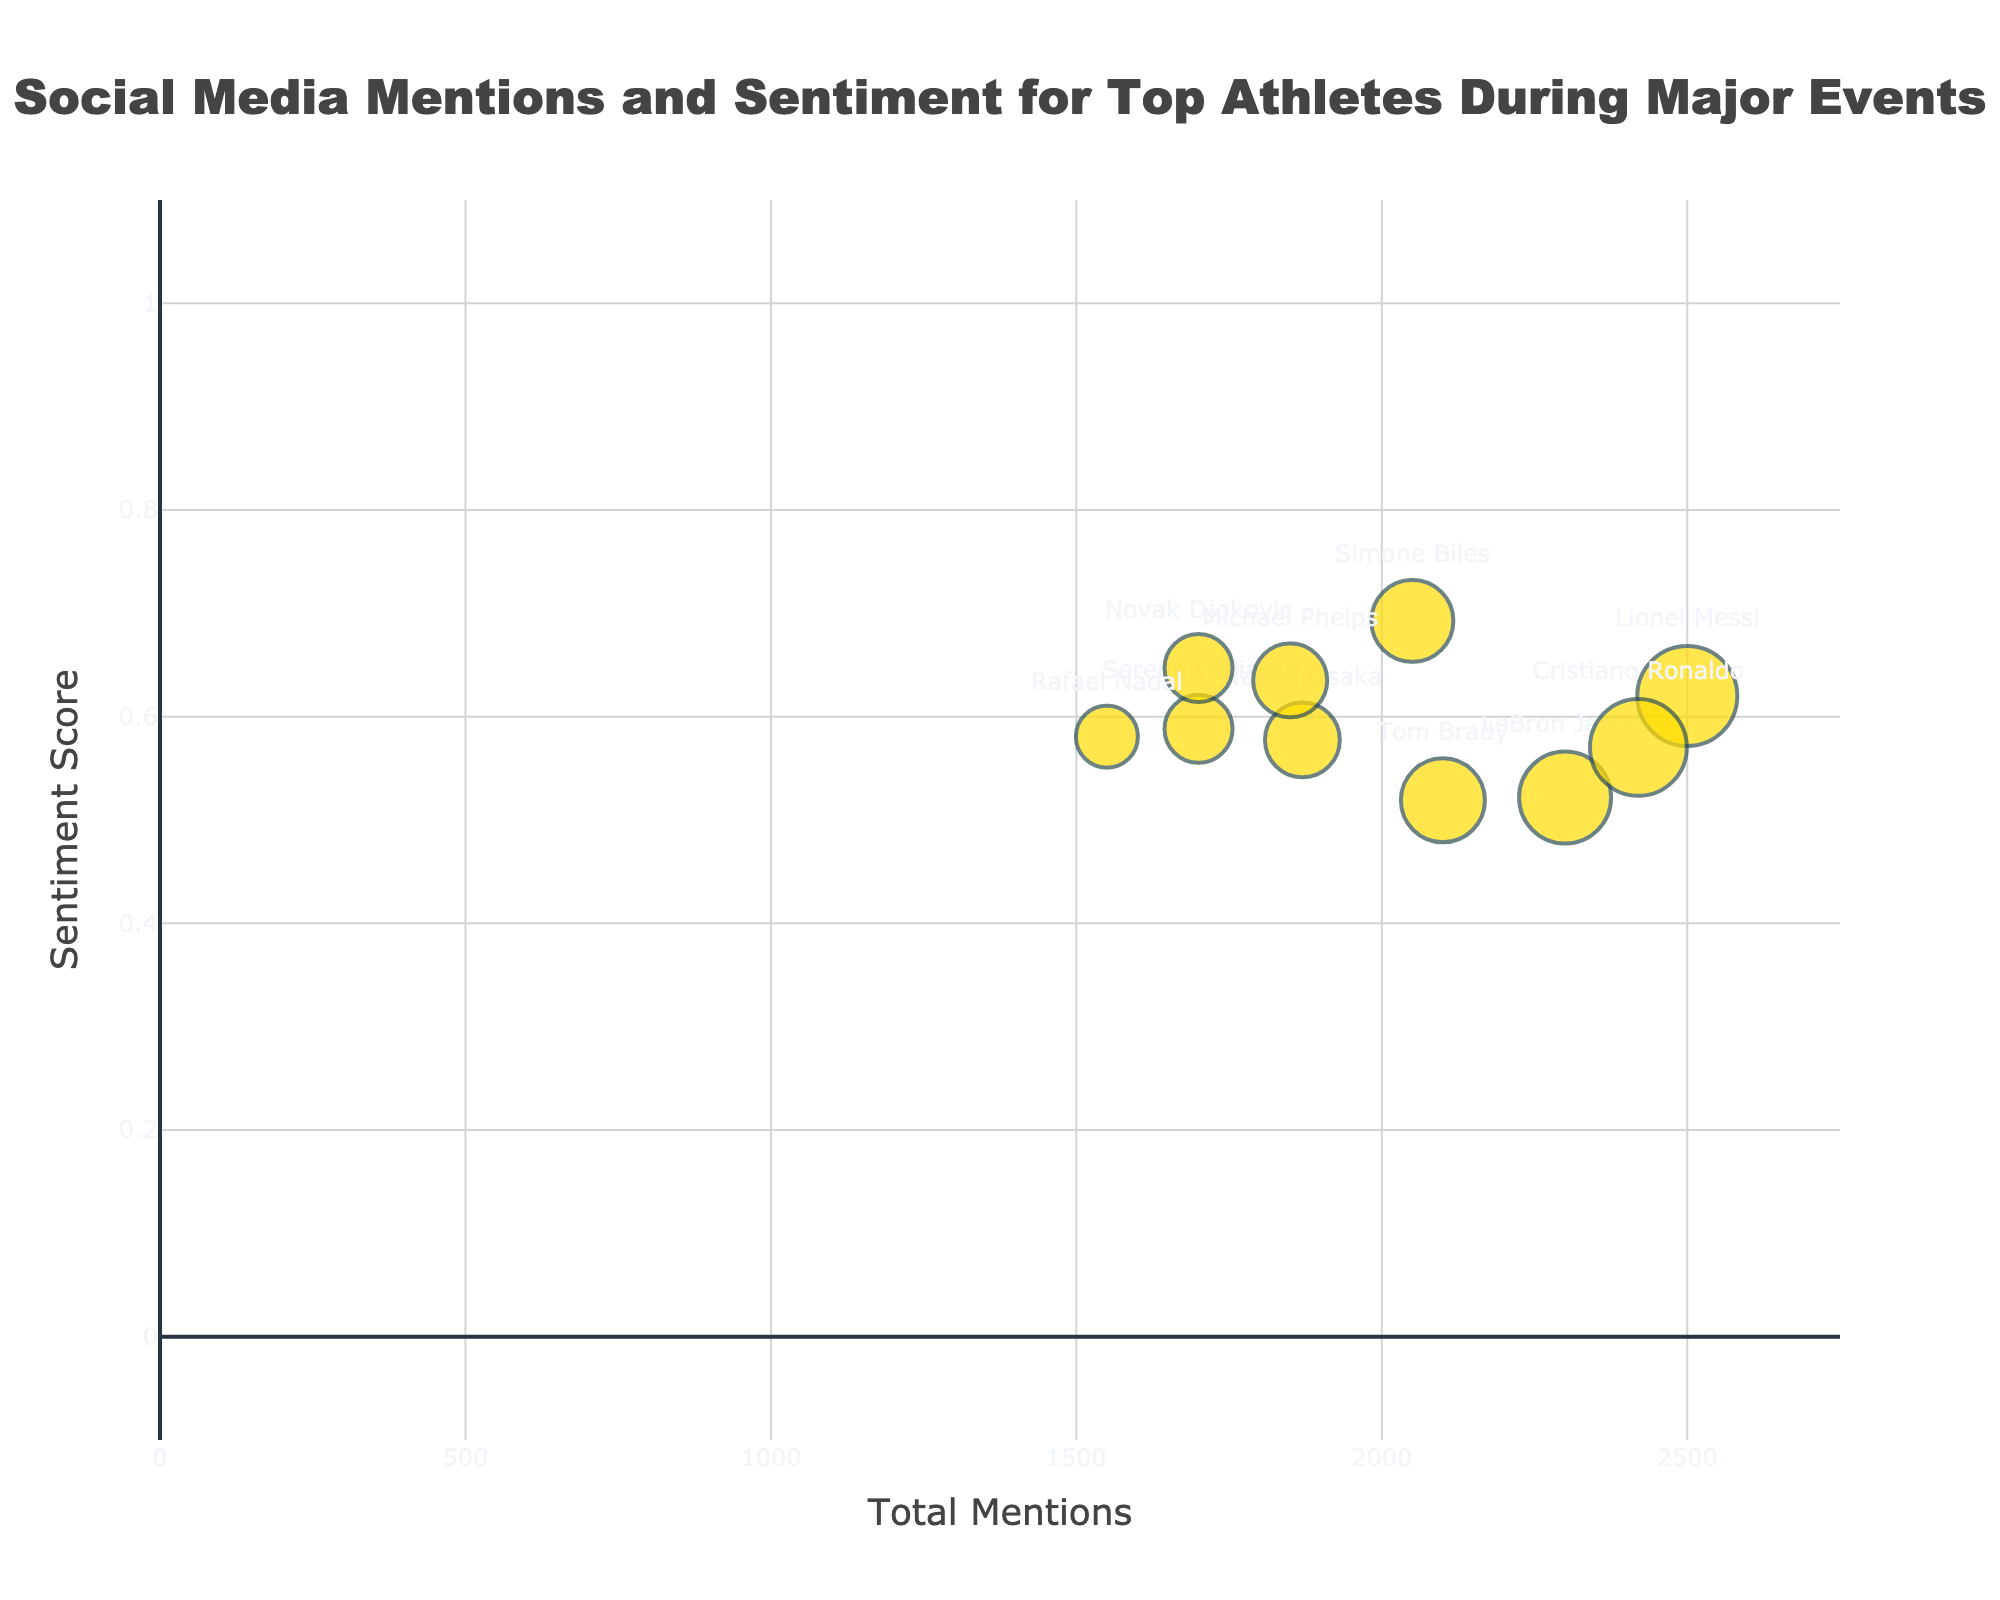What is the title of the chart? The title is typically located at the top of the chart and is often bold and centered. In this case, it is "Social Media Mentions and Sentiment for Top Athletes During Major Events".
Answer: Social Media Mentions and Sentiment for Top Athletes During Major Events What are the labels of the x-axis and y-axis? The x-axis label indicates what the horizontal measurements represent, and the y-axis label indicates what the vertical measurements represent. The x-axis label is "Total Mentions", and the y-axis label is "Sentiment Score".
Answer: Total Mentions and Sentiment Score Which athlete has the highest sentiment score? To find this, look for the bubble positioned highest on the y-axis, as it represents the sentiment score. In this chart, Simone Biles has the highest sentiment score.
Answer: Simone Biles Which event had the largest total social media mentions? Check the x-axis to find the bubble farthest to the right, which represents the highest total mentions. Lionel Messi’s bubble for the Copa America Final is farthest to the right.
Answer: Copa America Final (Lionel Messi) How many athletes are represented in the bubble chart? Count the individual bubbles in the chart, as each bubble represents a different athlete. There are ten bubbles, meaning ten athletes are represented.
Answer: 10 How does the sentiment score of LeBron James compare to that of Serena Williams? Compare the vertical positions of the bubbles for LeBron James (NBA Finals) and Serena Williams (Wimbledon) on the y-axis. LeBron James has a lower sentiment score than Serena Williams.
Answer: Lower What is the average sentiment score of the athletes? Sum the sentiment scores of all athletes and divide by the number of athletes. Sentiment scores are: 0.69, 0.72, 0.75, 0.7, 0.69, 0.68, 0.79, 0.75, 0.66, 0.76. The average is (0.69 + 0.72 + 0.75 + 0.7 + 0.69 + 0.68 + 0.79 + 0.75 + 0.66 + 0.76) / 10 = 7.19/10 = 0.719.
Answer: 0.719 What is the total number of social media mentions for Cristiano Ronaldo and Lionel Messi combined? Add the total mentions of both players. Cristiano Ronaldo: 1700+320+400 = 2420 and Lionel Messi: 1800+250+450 = 2500. The combined total is 2420 + 2500 = 4920.
Answer: 4920 Which athlete has the smallest bubble size and what event do they represent? The smallest bubble represents the athlete with the lowest total mentions. This is Rafael Nadal at the French Open.
Answer: Rafael Nadal (French Open) What color represents athletes with the highest sentiment score range? Look at the chart to see the color associated with the highest bubbles on the y-axis. Athletes with the highest sentiment scores (e.g., Simone Biles) have their bubbles colored in green (#2ECC40).
Answer: Green 